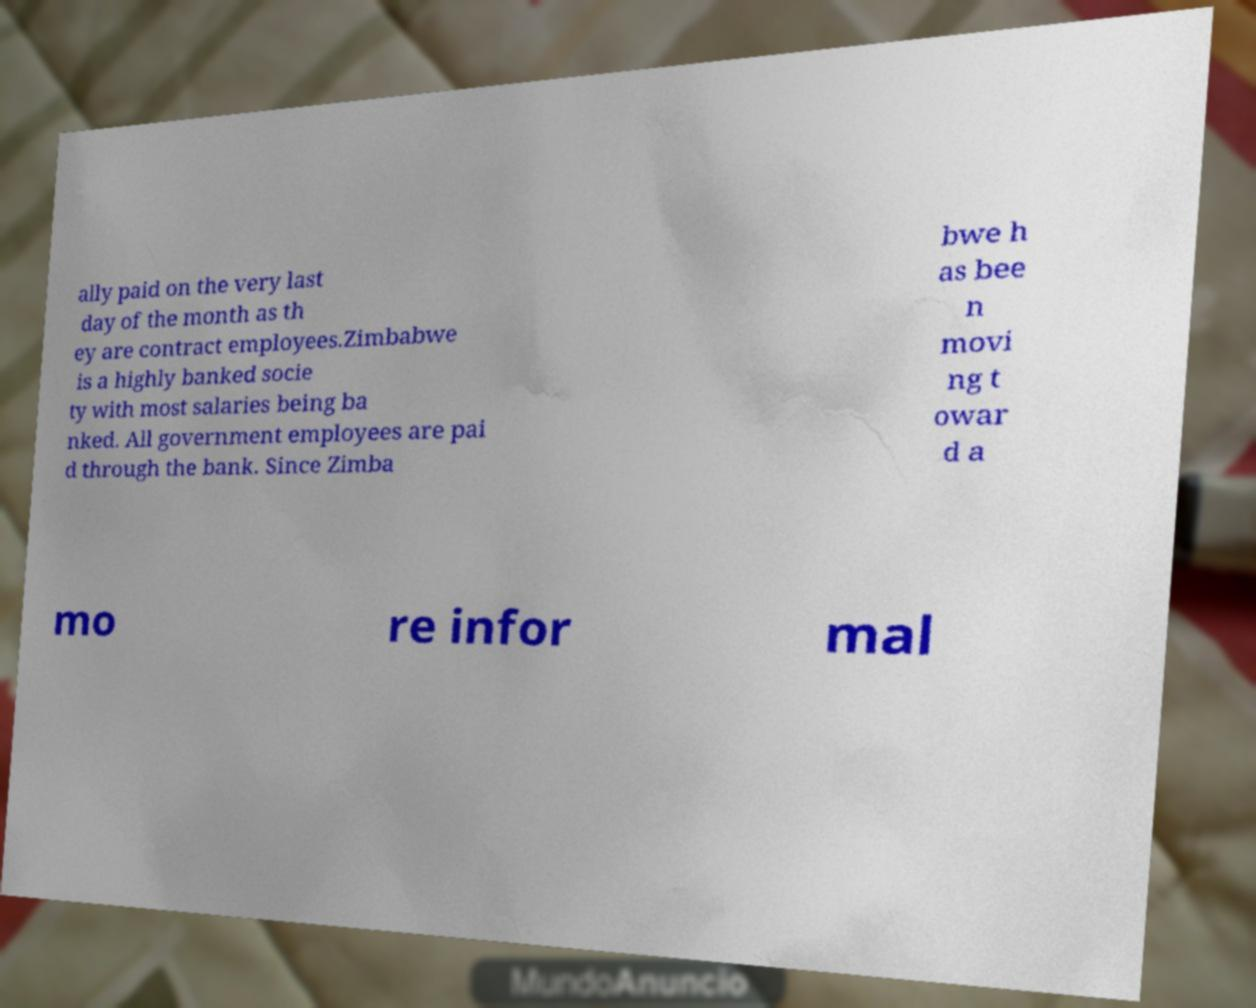Please read and relay the text visible in this image. What does it say? ally paid on the very last day of the month as th ey are contract employees.Zimbabwe is a highly banked socie ty with most salaries being ba nked. All government employees are pai d through the bank. Since Zimba bwe h as bee n movi ng t owar d a mo re infor mal 